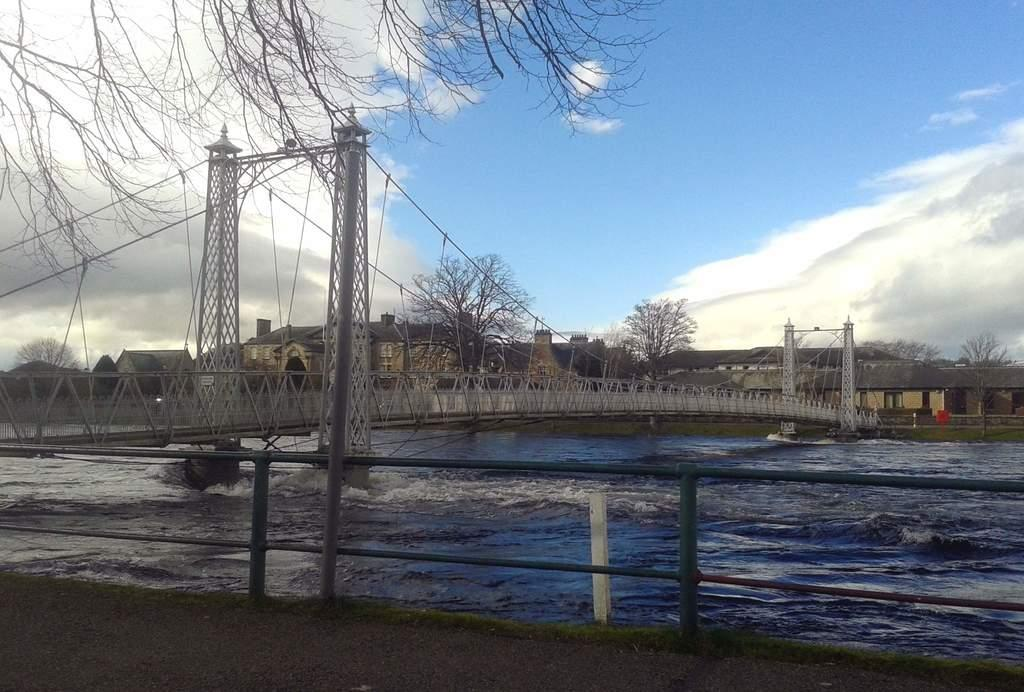What structure is present in the image? There is a bridge in the image. What is under the bridge? There is water under the bridge. What type of railing is present on the bridge? There is an iron railing in the image. What can be seen in the background of the image? There are trees, buildings, and the sky visible in the background of the image. What is the condition of the sky in the image? The sky is visible in the background of the image, and there are clouds present. Can you tell me how many cubs are swimming in the lake in the image? There is no lake or cubs present in the image; it features a bridge with water underneath. What type of muscle is being exercised by the person on the bridge in the image? There is no person present on the bridge in the image, so it is not possible to determine which muscles might be exercised. 